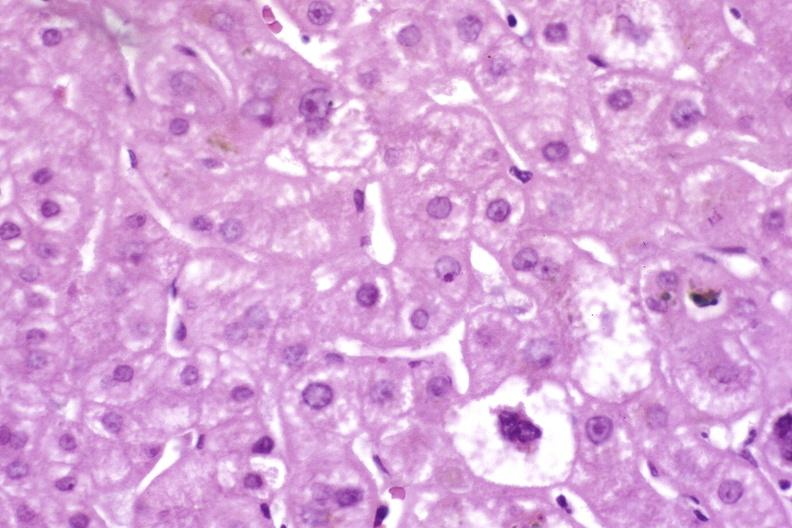s liver present?
Answer the question using a single word or phrase. Yes 